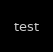<code> <loc_0><loc_0><loc_500><loc_500><_Python_>test</code> 